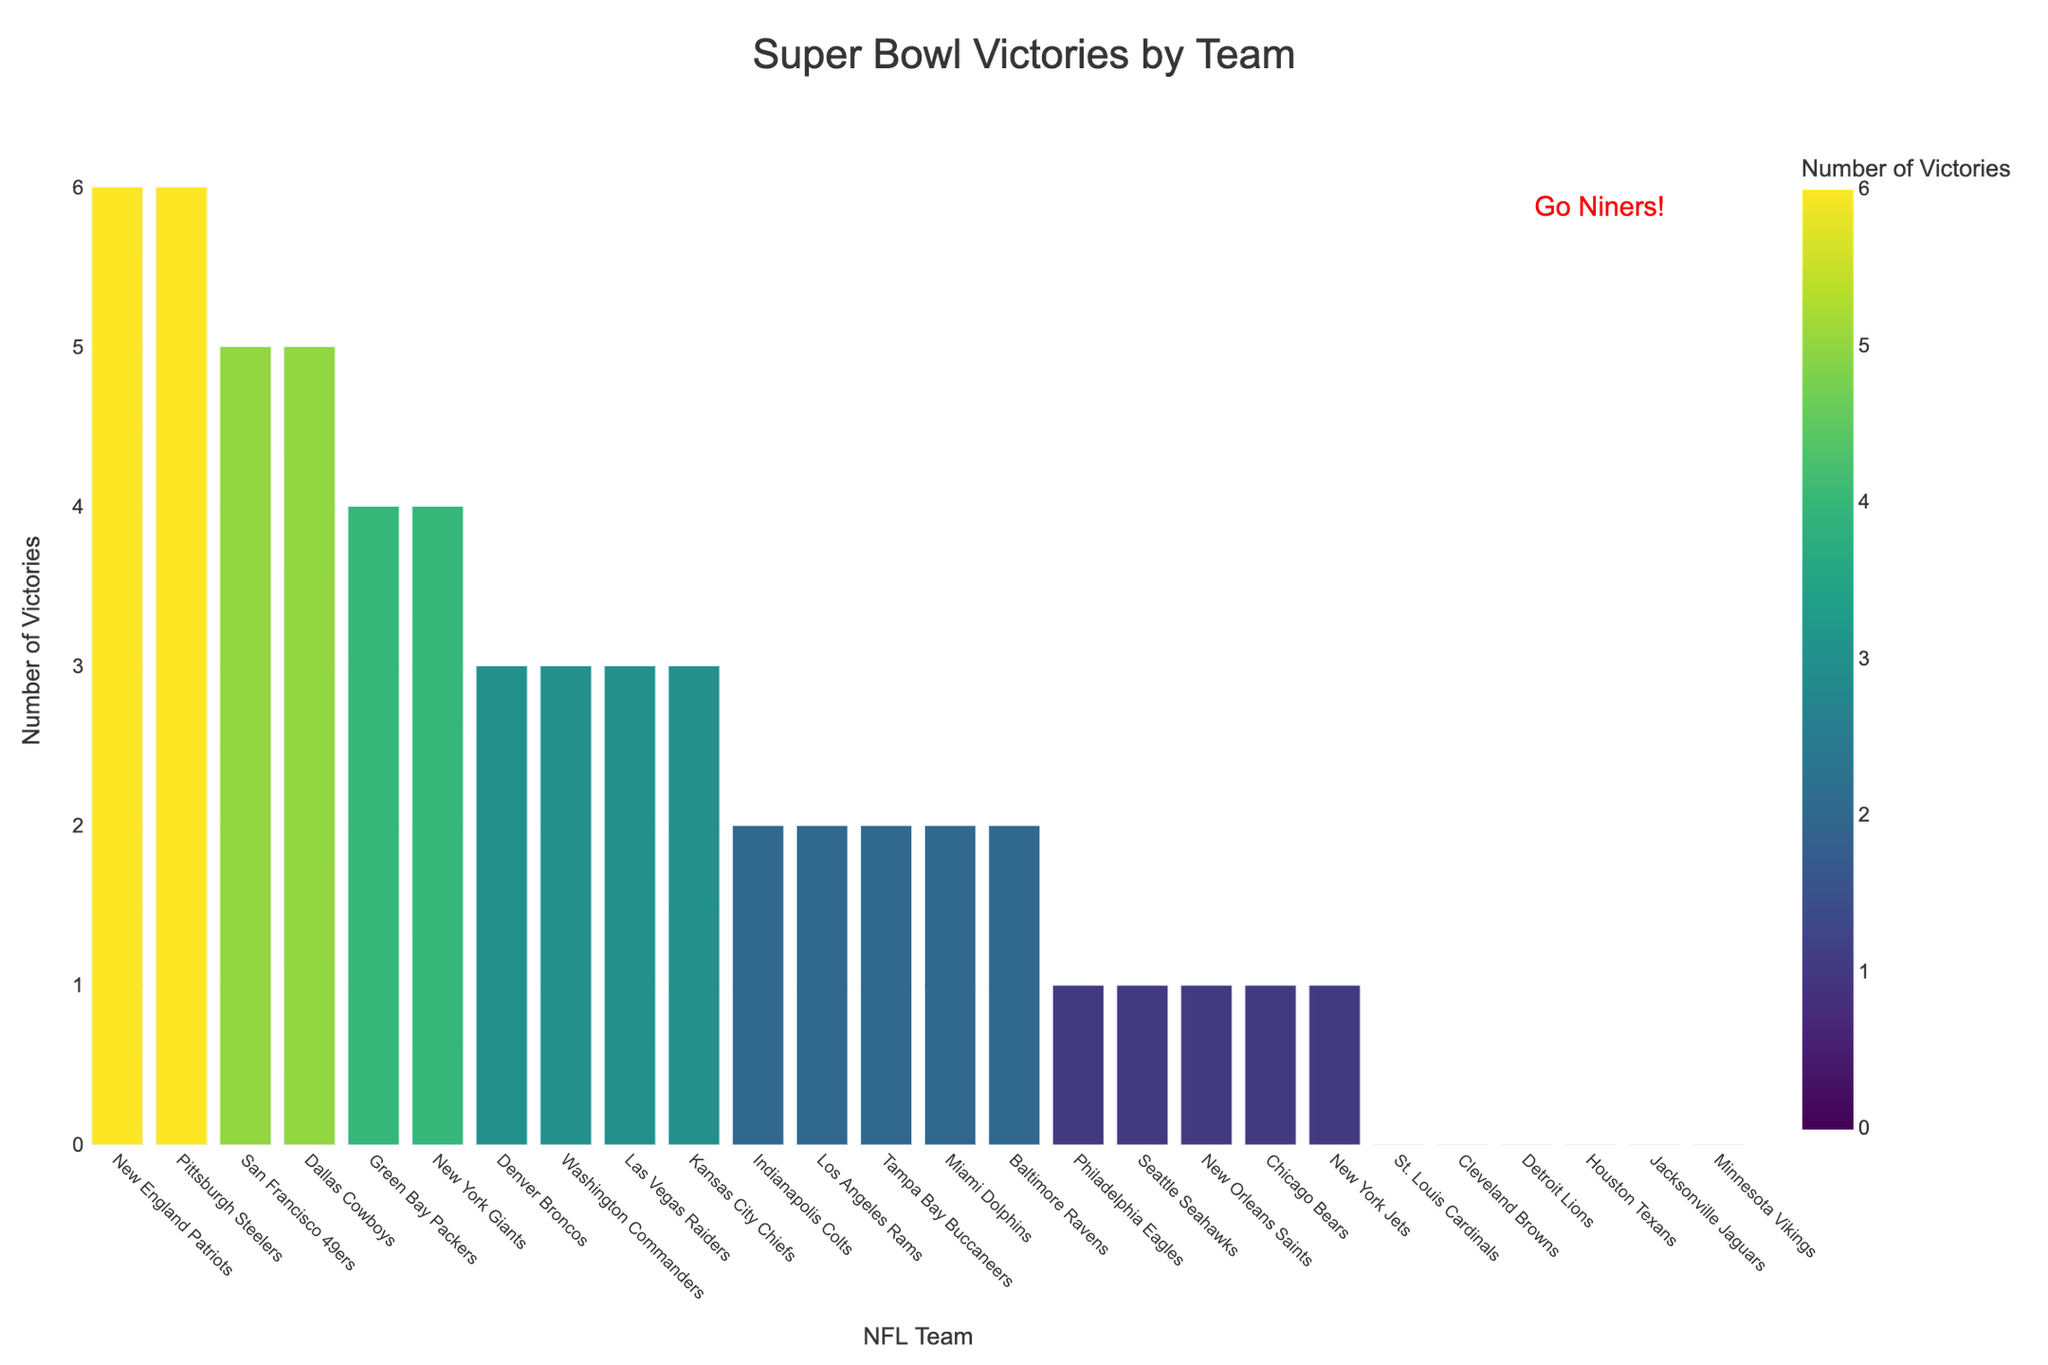What's the total number of Super Bowl wins for teams with 3 victories each? There are four teams with 3 Super Bowl victories: Denver Broncos, Washington Commanders, Las Vegas Raiders, and Kansas City Chiefs. Summing their victories (3 + 3 + 3 + 3) gives us 12.
Answer: 12 Which team has the tallest bar in the figure, and how many victories does it represent? The tallest bars represent both the New England Patriots and the Pittsburgh Steelers, each with 6 Super Bowl victories.
Answer: New England Patriots and Pittsburgh Steelers, 6 Which teams have more Super Bowl victories, the Dallas Cowboys or the Miami Dolphins? The Dallas Cowboys have 5 Super Bowl victories, whereas the Miami Dolphins have 2 victories. Therefore, the Dallas Cowboys have more Super Bowl victories.
Answer: Dallas Cowboys How many more victories do the Green Bay Packers have than the Philadelphia Eagles? The Green Bay Packers have 4 victories, and the Philadelphia Eagles have 1 victory. Subtracting these (4 - 1) gives us 3.
Answer: 3 Identify the teams that have only 1 Super Bowl victory and calculate their total number of victories. Teams with only 1 Super Bowl victory include the Philadelphia Eagles, Seattle Seahawks, New Orleans Saints, Chicago Bears, and New York Jets. Summing their victories (1 + 1 + 1 + 1 + 1) gives us 5.
Answer: 5 Which team is represented by the annotations "Go Niners!" and how many Super Bowl victories do they have? The annotation "Go Niners!" refers to the San Francisco 49ers, who have 5 Super Bowl victories.
Answer: San Francisco 49ers, 5 How many bars represent teams with 0 Super Bowl victories, and can you name them? There are six teams with 0 Super Bowl victories: St. Louis Cardinals, Cleveland Browns, Detroit Lions, Houston Texans, Jacksonville Jaguars, and Minnesota Vikings.
Answer: 6 Which team has fewer Super Bowl victories, the Tampa Bay Buccaneers or the New York Giants? The Tampa Bay Buccaneers have 2 Super Bowl victories, while the New York Giants have 4 victories. Thus, the Tampa Bay Buccaneers have fewer victories.
Answer: Tampa Bay Buccaneers What is the color of the bars representing teams with the highest number of victories? The bars representing teams with the highest number of victories (New England Patriots and Pittsburgh Steelers) are colored at the dark end of the Viridis color scale.
Answer: Dark color Compare the bar heights of the Baltimore Ravens and the Detroit Lions. Which is taller? The Baltimore Ravens have 2 victories, and the Detroit Lions have 0 victories. The bar for the Baltimore Ravens is therefore taller.
Answer: Baltimore Ravens 